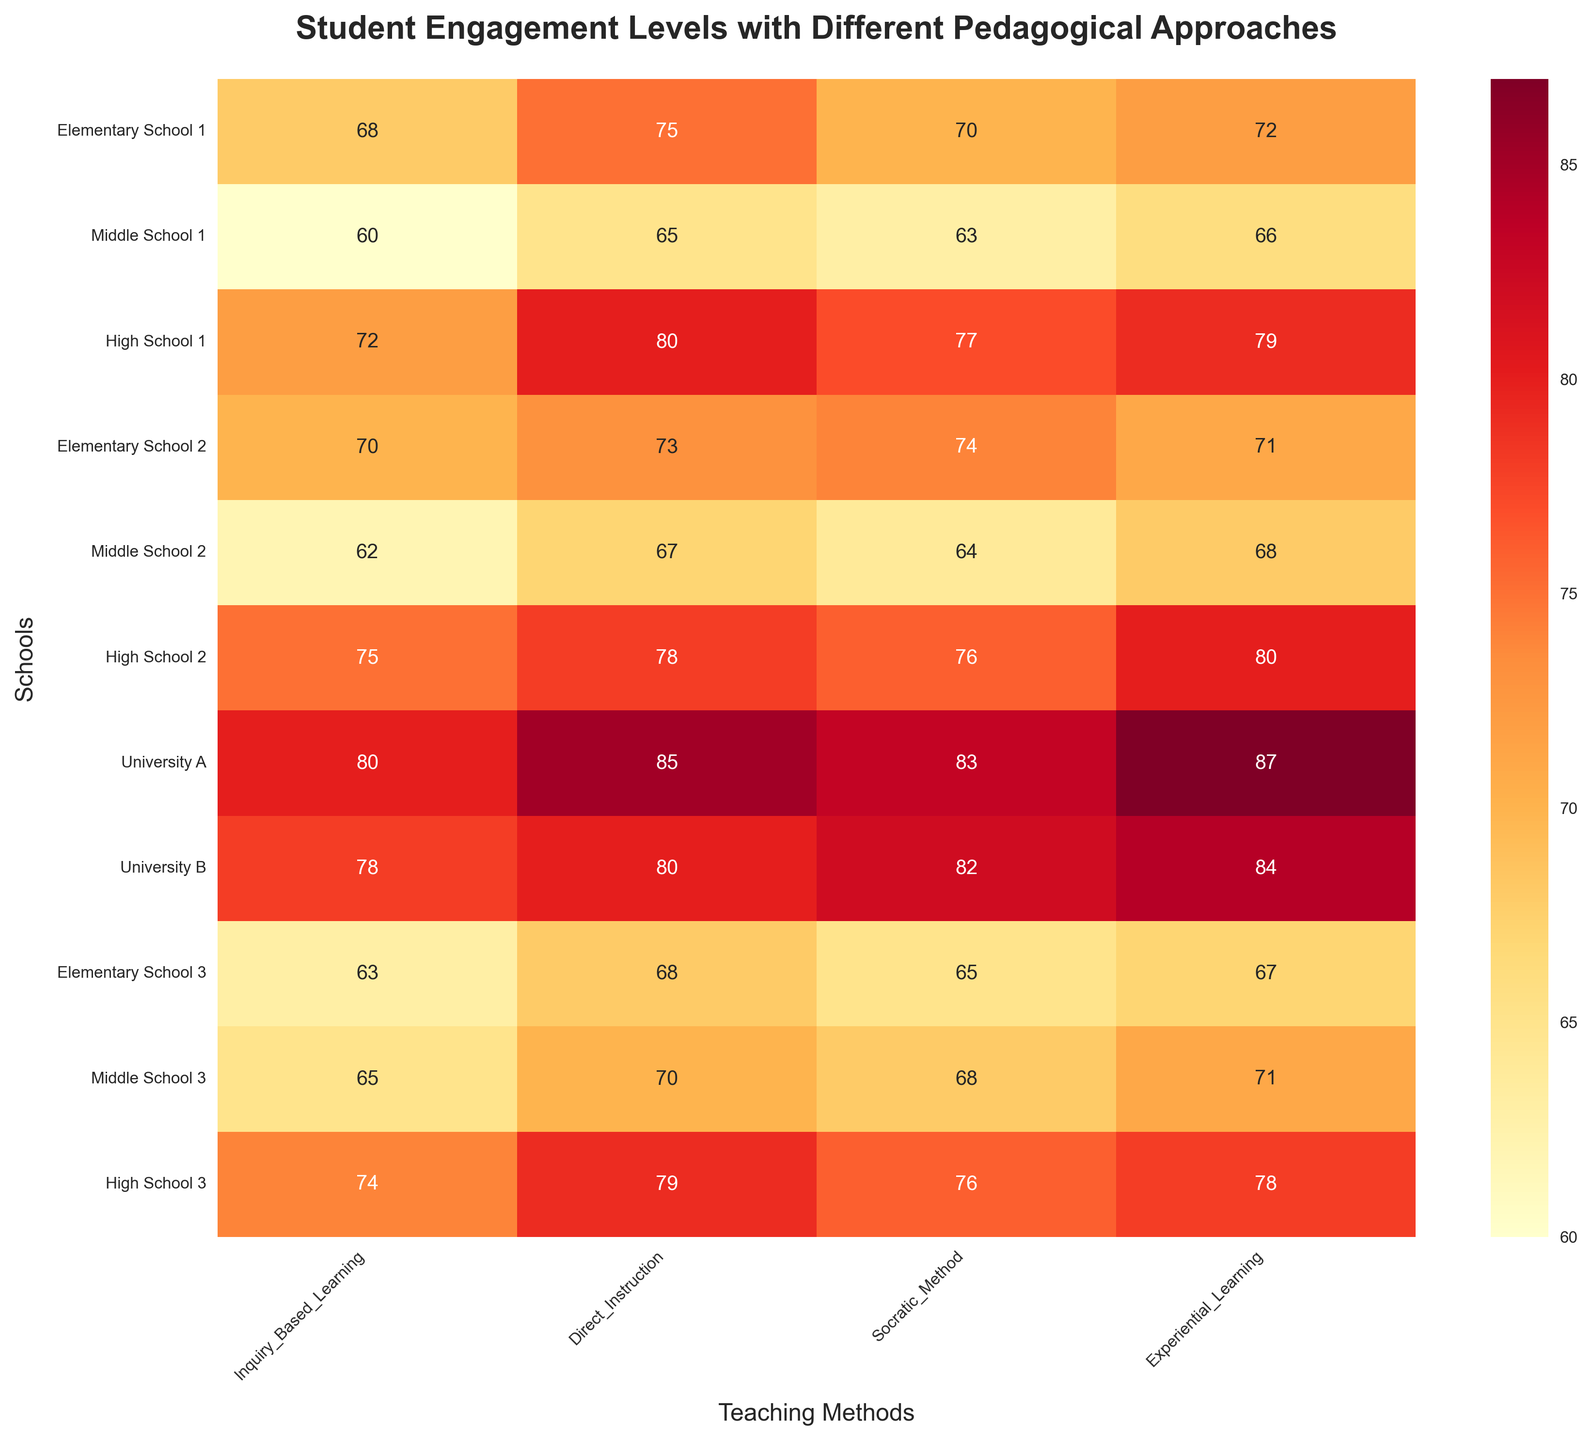What's the title of the heatmap? The title is prominently displayed at the top of the figure in bold and large font. It typically summarizes the main point of the data visualized.
Answer: Student Engagement Levels with Different Pedagogical Approaches What are the teaching methods represented on the x-axis? The x-axis labels are rotated and list the different traditional pedagogical approaches on the heatmap.
Answer: Inquiry-Based Learning, Direct Instruction, Socratic Method, Experiential Learning Which school has the highest engagement level in Inquiry-Based Learning? By scanning down the column under Inquiry-Based Learning, we see that University A has the highest value (80).
Answer: University A What's the average engagement level for Direct Instruction in all schools? Add the Direct Instruction values (75 + 65 + 80 + 73 + 67 + 78 + 85 + 80 + 68 + 70 + 79 = 820) and divide by the number of schools (11). 820 ÷ 11 = 74.55
Answer: 74.55 Which educational institution has the lowest combined engagement across all methods? Sum the values for each school and compare. Elementary School 3: 63+68+65+67=263, which is the lowest sum.
Answer: Elementary School 3 Compare the engagement levels between Urban and Rural schools for Socratic Method. Which type of school has higher engagement on average? Calculate the average for Urban schools (70+77+83+68=298, 298 ÷ 4 = 74.5) and Rural schools (63+76+65=204, 204 ÷ 3 = 68). Urban schools have a higher average.
Answer: Urban schools What is the standard deviation of engagement levels in Experiential Learning for all schools? Calculate the mean (727 ÷ 11 = 66.09), then use the formula for standard deviation: sqrt(sum of (each value - mean)^2 / number of schools).
Answer: Detailed calculation needed, approx 5.47 Does University B have higher engagement in Inquiry-Based Learning or Direct Instruction? Compare the two values for University B. Inquiry-Based Learning (78) vs Direct Instruction (80). Direct Instruction is higher.
Answer: Direct Instruction Identify the trend in engagement levels across different school types in Experiential Learning. Observing Urban, Suburban, and Rural schools for Experiential Learning column, we see Urban schools generally have higher engagement, followed by Suburban and Rural schools.
Answer: Urban > Suburban > Rural How does the engagement level in Socratic Method at High School 2 compare with the average engagement level in that method across all schools? Average engagement level for Socratic Method: (70+63+77+74+64+76+83+82+65+68+76 = 798, 798 ÷ 11 = 72.55). High School 2's Socratic Method engagement is 76 which is higher.
Answer: Higher 